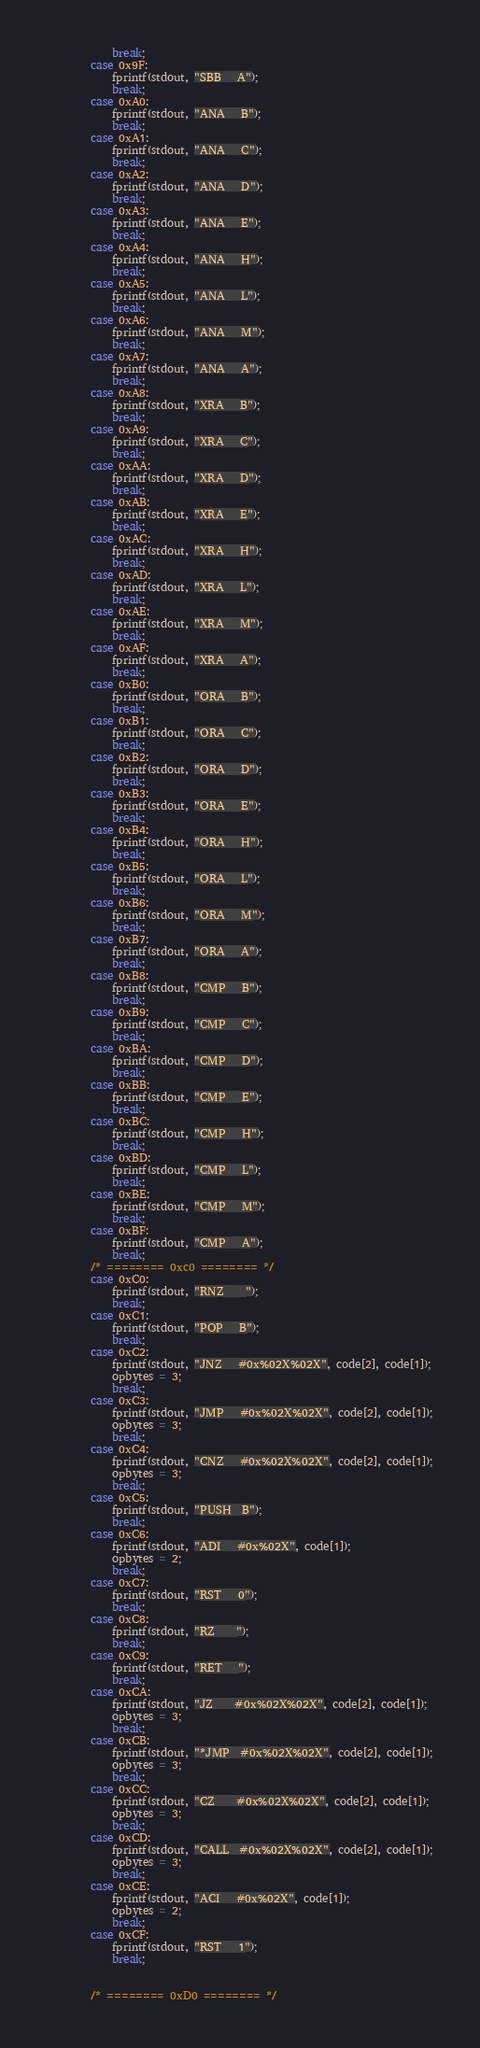<code> <loc_0><loc_0><loc_500><loc_500><_C_>            break;
        case 0x9F:
            fprintf(stdout, "SBB   A");
            break;
        case 0xA0:
            fprintf(stdout, "ANA   B");
            break;
        case 0xA1:
            fprintf(stdout, "ANA   C");
            break;
        case 0xA2:
            fprintf(stdout, "ANA   D");
            break;
        case 0xA3:
            fprintf(stdout, "ANA   E");
            break;
        case 0xA4:
            fprintf(stdout, "ANA   H");
            break;
        case 0xA5:
            fprintf(stdout, "ANA   L");
            break;
        case 0xA6:
            fprintf(stdout, "ANA   M");
            break;
        case 0xA7:
            fprintf(stdout, "ANA   A");
            break;
        case 0xA8:
            fprintf(stdout, "XRA   B");
            break;
        case 0xA9:
            fprintf(stdout, "XRA   C");
            break;
        case 0xAA:
            fprintf(stdout, "XRA   D");
            break;
        case 0xAB:
            fprintf(stdout, "XRA   E");
            break;
        case 0xAC:
            fprintf(stdout, "XRA   H");
            break;
        case 0xAD:
            fprintf(stdout, "XRA   L");
            break;
        case 0xAE:
            fprintf(stdout, "XRA   M");
            break;
        case 0xAF:
            fprintf(stdout, "XRA   A");
            break;
        case 0xB0:
            fprintf(stdout, "ORA   B");
            break;
        case 0xB1:
            fprintf(stdout, "ORA   C");
            break;
        case 0xB2:
            fprintf(stdout, "ORA   D");
            break;
        case 0xB3:
            fprintf(stdout, "ORA   E");
            break;
        case 0xB4:
            fprintf(stdout, "ORA   H");
            break;
        case 0xB5:
            fprintf(stdout, "ORA   L");
            break;
        case 0xB6:
            fprintf(stdout, "ORA   M");
            break;
        case 0xB7:
            fprintf(stdout, "ORA   A");
            break;
        case 0xB8:
            fprintf(stdout, "CMP   B");
            break;
        case 0xB9:
            fprintf(stdout, "CMP   C");
            break;
        case 0xBA:
            fprintf(stdout, "CMP   D");
            break;
        case 0xBB:
            fprintf(stdout, "CMP   E");
            break;
        case 0xBC:
            fprintf(stdout, "CMP   H");
            break;
        case 0xBD:
            fprintf(stdout, "CMP   L");
            break;
        case 0xBE:
            fprintf(stdout, "CMP   M");
            break;
        case 0xBF:
            fprintf(stdout, "CMP   A");
            break;
        /* ======== 0xc0 ======== */
        case 0xC0:
            fprintf(stdout, "RNZ    ");
            break;
        case 0xC1:
            fprintf(stdout, "POP   B");
            break;
        case 0xC2:
            fprintf(stdout, "JNZ   #0x%02X%02X", code[2], code[1]);
            opbytes = 3;
            break;
        case 0xC3:
            fprintf(stdout, "JMP   #0x%02X%02X", code[2], code[1]);
            opbytes = 3;
            break;
        case 0xC4:
            fprintf(stdout, "CNZ   #0x%02X%02X", code[2], code[1]);
            opbytes = 3;
            break;
        case 0xC5:
            fprintf(stdout, "PUSH  B");
            break;
        case 0xC6:
            fprintf(stdout, "ADI   #0x%02X", code[1]);
            opbytes = 2;
            break;
        case 0xC7:
            fprintf(stdout, "RST   0");
            break;
        case 0xC8:
            fprintf(stdout, "RZ    ");
            break;
        case 0xC9:
            fprintf(stdout, "RET   ");
            break;
        case 0xCA:
            fprintf(stdout, "JZ    #0x%02X%02X", code[2], code[1]);
            opbytes = 3;
            break;
        case 0xCB:
            fprintf(stdout, "*JMP  #0x%02X%02X", code[2], code[1]);
            opbytes = 3;
            break;
        case 0xCC:
            fprintf(stdout, "CZ    #0x%02X%02X", code[2], code[1]);
            opbytes = 3;
            break;
        case 0xCD:
            fprintf(stdout, "CALL  #0x%02X%02X", code[2], code[1]);
            opbytes = 3;
            break;
        case 0xCE:
            fprintf(stdout, "ACI   #0x%02X", code[1]);
            opbytes = 2;
            break;
        case 0xCF:
            fprintf(stdout, "RST   1");
            break;


        /* ======== 0xD0 ======== */</code> 